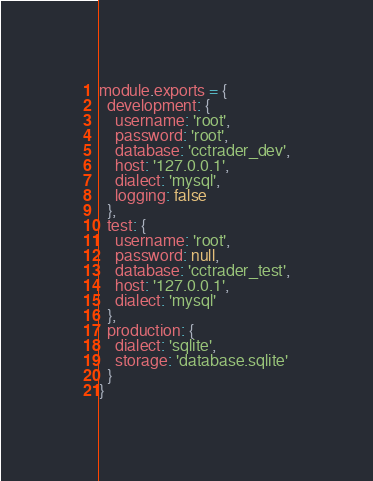<code> <loc_0><loc_0><loc_500><loc_500><_JavaScript_>module.exports = {
  development: {
    username: 'root',
    password: 'root',
    database: 'cctrader_dev',
    host: '127.0.0.1',
    dialect: 'mysql',
    logging: false
  },
  test: {
    username: 'root',
    password: null,
    database: 'cctrader_test',
    host: '127.0.0.1',
    dialect: 'mysql'
  },
  production: {
    dialect: 'sqlite',
    storage: 'database.sqlite'
  }
}
</code> 